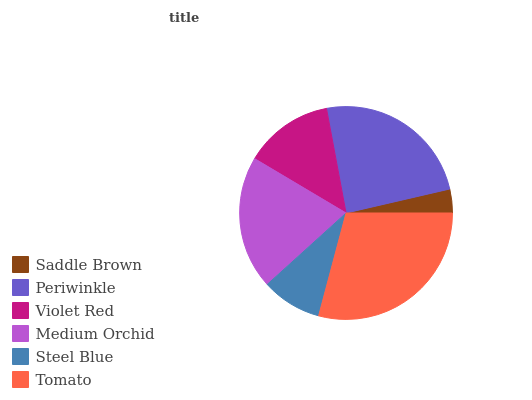Is Saddle Brown the minimum?
Answer yes or no. Yes. Is Tomato the maximum?
Answer yes or no. Yes. Is Periwinkle the minimum?
Answer yes or no. No. Is Periwinkle the maximum?
Answer yes or no. No. Is Periwinkle greater than Saddle Brown?
Answer yes or no. Yes. Is Saddle Brown less than Periwinkle?
Answer yes or no. Yes. Is Saddle Brown greater than Periwinkle?
Answer yes or no. No. Is Periwinkle less than Saddle Brown?
Answer yes or no. No. Is Medium Orchid the high median?
Answer yes or no. Yes. Is Violet Red the low median?
Answer yes or no. Yes. Is Saddle Brown the high median?
Answer yes or no. No. Is Medium Orchid the low median?
Answer yes or no. No. 